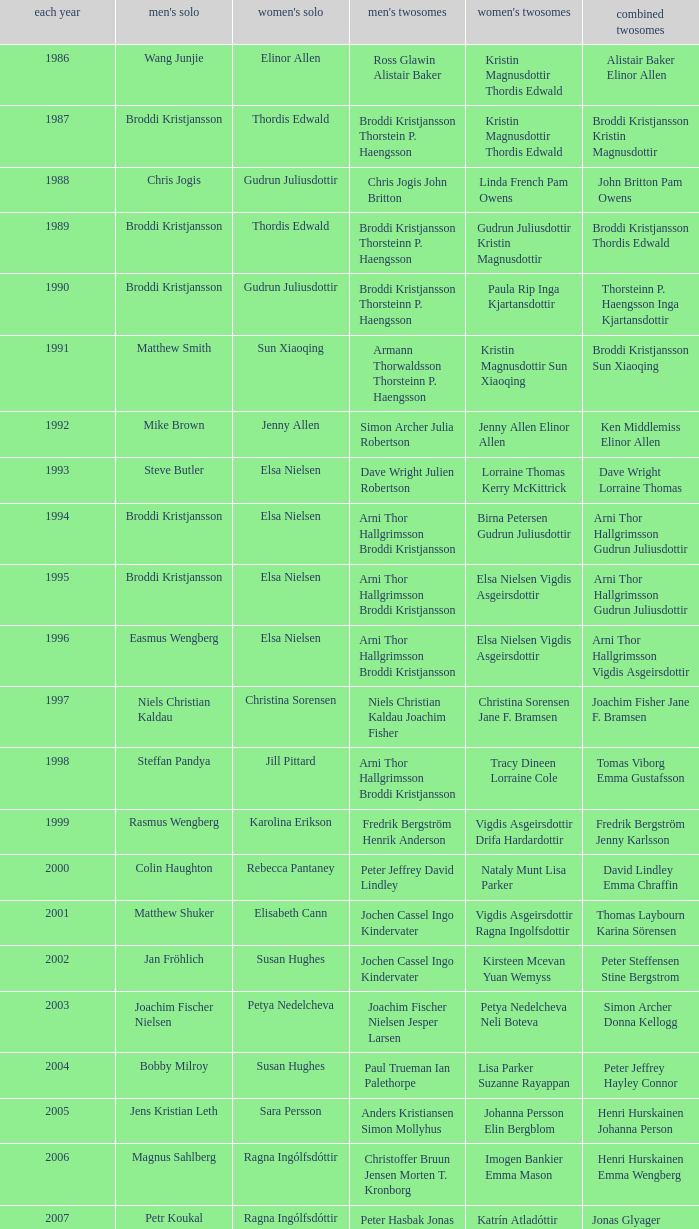In which women's doubles did Wang Junjie play men's singles? Kristin Magnusdottir Thordis Edwald. Would you be able to parse every entry in this table? {'header': ['each year', "men's solo", "women's solo", "men's twosomes", "women's twosomes", 'combined twosomes'], 'rows': [['1986', 'Wang Junjie', 'Elinor Allen', 'Ross Glawin Alistair Baker', 'Kristin Magnusdottir Thordis Edwald', 'Alistair Baker Elinor Allen'], ['1987', 'Broddi Kristjansson', 'Thordis Edwald', 'Broddi Kristjansson Thorstein P. Haengsson', 'Kristin Magnusdottir Thordis Edwald', 'Broddi Kristjansson Kristin Magnusdottir'], ['1988', 'Chris Jogis', 'Gudrun Juliusdottir', 'Chris Jogis John Britton', 'Linda French Pam Owens', 'John Britton Pam Owens'], ['1989', 'Broddi Kristjansson', 'Thordis Edwald', 'Broddi Kristjansson Thorsteinn P. Haengsson', 'Gudrun Juliusdottir Kristin Magnusdottir', 'Broddi Kristjansson Thordis Edwald'], ['1990', 'Broddi Kristjansson', 'Gudrun Juliusdottir', 'Broddi Kristjansson Thorsteinn P. Haengsson', 'Paula Rip Inga Kjartansdottir', 'Thorsteinn P. Haengsson Inga Kjartansdottir'], ['1991', 'Matthew Smith', 'Sun Xiaoqing', 'Armann Thorwaldsson Thorsteinn P. Haengsson', 'Kristin Magnusdottir Sun Xiaoqing', 'Broddi Kristjansson Sun Xiaoqing'], ['1992', 'Mike Brown', 'Jenny Allen', 'Simon Archer Julia Robertson', 'Jenny Allen Elinor Allen', 'Ken Middlemiss Elinor Allen'], ['1993', 'Steve Butler', 'Elsa Nielsen', 'Dave Wright Julien Robertson', 'Lorraine Thomas Kerry McKittrick', 'Dave Wright Lorraine Thomas'], ['1994', 'Broddi Kristjansson', 'Elsa Nielsen', 'Arni Thor Hallgrimsson Broddi Kristjansson', 'Birna Petersen Gudrun Juliusdottir', 'Arni Thor Hallgrimsson Gudrun Juliusdottir'], ['1995', 'Broddi Kristjansson', 'Elsa Nielsen', 'Arni Thor Hallgrimsson Broddi Kristjansson', 'Elsa Nielsen Vigdis Asgeirsdottir', 'Arni Thor Hallgrimsson Gudrun Juliusdottir'], ['1996', 'Easmus Wengberg', 'Elsa Nielsen', 'Arni Thor Hallgrimsson Broddi Kristjansson', 'Elsa Nielsen Vigdis Asgeirsdottir', 'Arni Thor Hallgrimsson Vigdis Asgeirsdottir'], ['1997', 'Niels Christian Kaldau', 'Christina Sorensen', 'Niels Christian Kaldau Joachim Fisher', 'Christina Sorensen Jane F. Bramsen', 'Joachim Fisher Jane F. Bramsen'], ['1998', 'Steffan Pandya', 'Jill Pittard', 'Arni Thor Hallgrimsson Broddi Kristjansson', 'Tracy Dineen Lorraine Cole', 'Tomas Viborg Emma Gustafsson'], ['1999', 'Rasmus Wengberg', 'Karolina Erikson', 'Fredrik Bergström Henrik Anderson', 'Vigdis Asgeirsdottir Drifa Hardardottir', 'Fredrik Bergström Jenny Karlsson'], ['2000', 'Colin Haughton', 'Rebecca Pantaney', 'Peter Jeffrey David Lindley', 'Nataly Munt Lisa Parker', 'David Lindley Emma Chraffin'], ['2001', 'Matthew Shuker', 'Elisabeth Cann', 'Jochen Cassel Ingo Kindervater', 'Vigdis Asgeirsdottir Ragna Ingolfsdottir', 'Thomas Laybourn Karina Sörensen'], ['2002', 'Jan Fröhlich', 'Susan Hughes', 'Jochen Cassel Ingo Kindervater', 'Kirsteen Mcevan Yuan Wemyss', 'Peter Steffensen Stine Bergstrom'], ['2003', 'Joachim Fischer Nielsen', 'Petya Nedelcheva', 'Joachim Fischer Nielsen Jesper Larsen', 'Petya Nedelcheva Neli Boteva', 'Simon Archer Donna Kellogg'], ['2004', 'Bobby Milroy', 'Susan Hughes', 'Paul Trueman Ian Palethorpe', 'Lisa Parker Suzanne Rayappan', 'Peter Jeffrey Hayley Connor'], ['2005', 'Jens Kristian Leth', 'Sara Persson', 'Anders Kristiansen Simon Mollyhus', 'Johanna Persson Elin Bergblom', 'Henri Hurskainen Johanna Person'], ['2006', 'Magnus Sahlberg', 'Ragna Ingólfsdóttir', 'Christoffer Bruun Jensen Morten T. Kronborg', 'Imogen Bankier Emma Mason', 'Henri Hurskainen Emma Wengberg'], ['2007', 'Petr Koukal', 'Ragna Ingólfsdóttir', 'Peter Hasbak Jonas Glyager Jensen', 'Katrín Atladóttir Ragna Ingólfsdóttir', 'Jonas Glyager Jensen Maria Kaaberböl Thorberg'], ['2008', 'No competition', 'No competition', 'No competition', 'No competition', 'No competition'], ['2009', 'Christian Lind Thomsen', 'Ragna Ingólfsdóttir', 'Anders Skaarup Rasmussen René Lindskow', 'Ragna Ingólfsdóttir Snjólaug Jóhannsdóttir', 'Theis Christiansen Joan Christiansen'], ['2010', 'Kim Bruun', 'Ragna Ingólfsdóttir', 'Emil Holst Mikkel Mikkelsen', 'Katrín Atladóttir Ragna Ingólfsdóttir', 'Frederik Colberg Mette Poulsen'], ['2011', 'Mathias Borg', 'Ragna Ingólfsdóttir', 'Thomas Dew-Hattens Mathias Kany', 'Tinna Helgadóttir Snjólaug Jóhannsdóttir', 'Thomas Dew-Hattens Louise Hansen'], ['2012', 'Chou Tien-chen', 'Chiang Mei-hui', 'Joe Morgan Nic Strange', 'Lee So-hee Shin Seung-chan', 'Chou Tien-chen Chiang Mei-hui']]} 